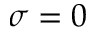Convert formula to latex. <formula><loc_0><loc_0><loc_500><loc_500>\sigma = 0</formula> 